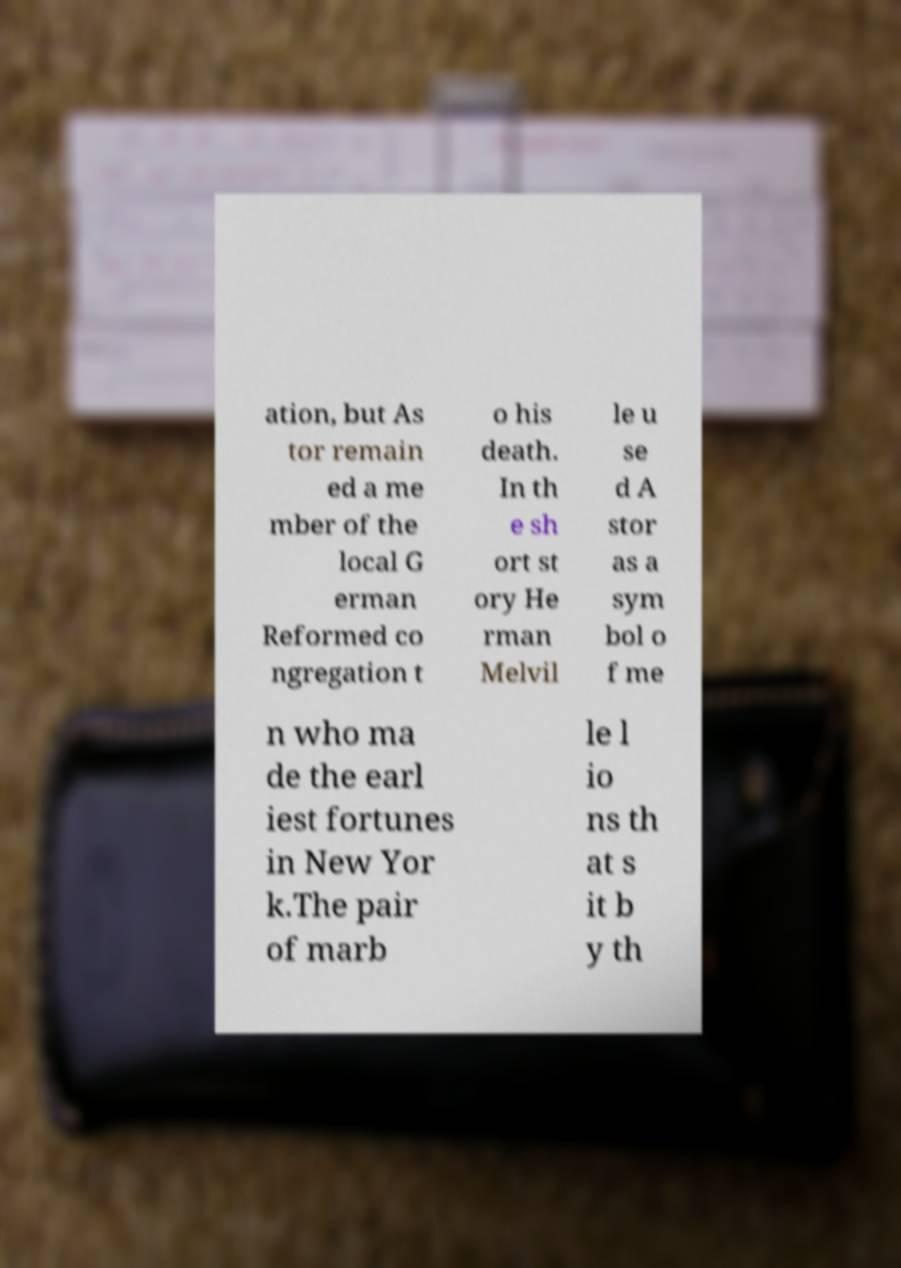Can you accurately transcribe the text from the provided image for me? ation, but As tor remain ed a me mber of the local G erman Reformed co ngregation t o his death. In th e sh ort st ory He rman Melvil le u se d A stor as a sym bol o f me n who ma de the earl iest fortunes in New Yor k.The pair of marb le l io ns th at s it b y th 